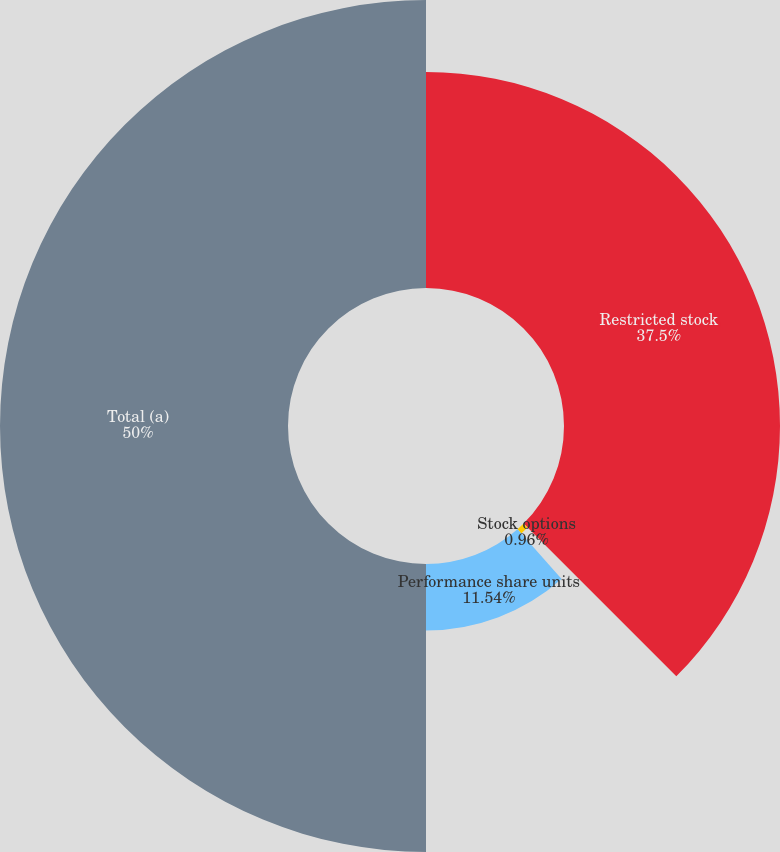<chart> <loc_0><loc_0><loc_500><loc_500><pie_chart><fcel>Restricted stock<fcel>Stock options<fcel>Performance share units<fcel>Total (a)<nl><fcel>37.5%<fcel>0.96%<fcel>11.54%<fcel>50.0%<nl></chart> 